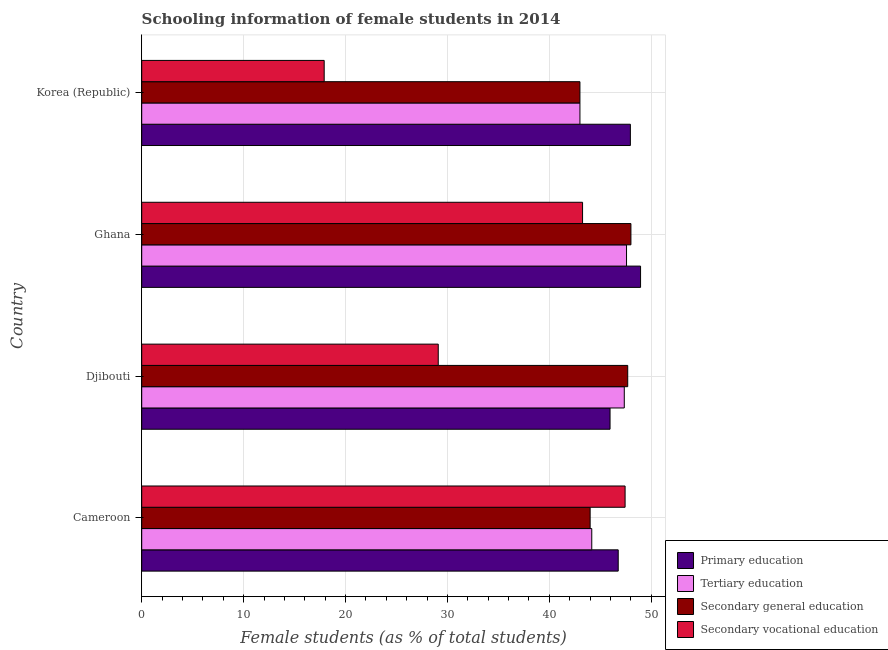How many groups of bars are there?
Your answer should be very brief. 4. How many bars are there on the 3rd tick from the bottom?
Give a very brief answer. 4. What is the label of the 2nd group of bars from the top?
Give a very brief answer. Ghana. In how many cases, is the number of bars for a given country not equal to the number of legend labels?
Offer a terse response. 0. What is the percentage of female students in secondary education in Cameroon?
Keep it short and to the point. 44. Across all countries, what is the maximum percentage of female students in secondary vocational education?
Make the answer very short. 47.43. Across all countries, what is the minimum percentage of female students in secondary education?
Keep it short and to the point. 43. In which country was the percentage of female students in secondary education maximum?
Offer a very short reply. Ghana. What is the total percentage of female students in secondary education in the graph?
Ensure brevity in your answer.  182.7. What is the difference between the percentage of female students in secondary vocational education in Korea (Republic) and the percentage of female students in secondary education in Djibouti?
Offer a very short reply. -29.79. What is the average percentage of female students in tertiary education per country?
Your response must be concise. 45.52. What is the difference between the percentage of female students in tertiary education and percentage of female students in secondary vocational education in Djibouti?
Provide a short and direct response. 18.26. What is the ratio of the percentage of female students in secondary vocational education in Djibouti to that in Korea (Republic)?
Give a very brief answer. 1.62. What is the difference between the highest and the second highest percentage of female students in tertiary education?
Your answer should be very brief. 0.22. What is the difference between the highest and the lowest percentage of female students in secondary vocational education?
Your answer should be very brief. 29.53. Is the sum of the percentage of female students in secondary education in Cameroon and Korea (Republic) greater than the maximum percentage of female students in tertiary education across all countries?
Keep it short and to the point. Yes. Is it the case that in every country, the sum of the percentage of female students in primary education and percentage of female students in secondary vocational education is greater than the sum of percentage of female students in secondary education and percentage of female students in tertiary education?
Give a very brief answer. No. Is it the case that in every country, the sum of the percentage of female students in primary education and percentage of female students in tertiary education is greater than the percentage of female students in secondary education?
Make the answer very short. Yes. How many bars are there?
Ensure brevity in your answer.  16. Are all the bars in the graph horizontal?
Keep it short and to the point. Yes. What is the difference between two consecutive major ticks on the X-axis?
Keep it short and to the point. 10. Are the values on the major ticks of X-axis written in scientific E-notation?
Give a very brief answer. No. Does the graph contain any zero values?
Ensure brevity in your answer.  No. Does the graph contain grids?
Offer a very short reply. Yes. Where does the legend appear in the graph?
Offer a very short reply. Bottom right. How many legend labels are there?
Ensure brevity in your answer.  4. What is the title of the graph?
Your answer should be very brief. Schooling information of female students in 2014. What is the label or title of the X-axis?
Your answer should be very brief. Female students (as % of total students). What is the label or title of the Y-axis?
Offer a very short reply. Country. What is the Female students (as % of total students) in Primary education in Cameroon?
Your response must be concise. 46.76. What is the Female students (as % of total students) in Tertiary education in Cameroon?
Keep it short and to the point. 44.16. What is the Female students (as % of total students) of Secondary general education in Cameroon?
Keep it short and to the point. 44. What is the Female students (as % of total students) in Secondary vocational education in Cameroon?
Your response must be concise. 47.43. What is the Female students (as % of total students) in Primary education in Djibouti?
Your answer should be compact. 45.96. What is the Female students (as % of total students) of Tertiary education in Djibouti?
Give a very brief answer. 47.35. What is the Female students (as % of total students) of Secondary general education in Djibouti?
Give a very brief answer. 47.69. What is the Female students (as % of total students) of Secondary vocational education in Djibouti?
Your answer should be compact. 29.1. What is the Female students (as % of total students) in Primary education in Ghana?
Provide a short and direct response. 48.95. What is the Female students (as % of total students) in Tertiary education in Ghana?
Make the answer very short. 47.58. What is the Female students (as % of total students) of Secondary general education in Ghana?
Provide a short and direct response. 48.01. What is the Female students (as % of total students) of Secondary vocational education in Ghana?
Offer a terse response. 43.26. What is the Female students (as % of total students) of Primary education in Korea (Republic)?
Offer a terse response. 47.95. What is the Female students (as % of total students) in Tertiary education in Korea (Republic)?
Your answer should be very brief. 43. What is the Female students (as % of total students) of Secondary general education in Korea (Republic)?
Make the answer very short. 43. What is the Female students (as % of total students) in Secondary vocational education in Korea (Republic)?
Give a very brief answer. 17.91. Across all countries, what is the maximum Female students (as % of total students) of Primary education?
Your answer should be very brief. 48.95. Across all countries, what is the maximum Female students (as % of total students) in Tertiary education?
Provide a short and direct response. 47.58. Across all countries, what is the maximum Female students (as % of total students) of Secondary general education?
Provide a succinct answer. 48.01. Across all countries, what is the maximum Female students (as % of total students) in Secondary vocational education?
Your answer should be compact. 47.43. Across all countries, what is the minimum Female students (as % of total students) of Primary education?
Your answer should be very brief. 45.96. Across all countries, what is the minimum Female students (as % of total students) in Tertiary education?
Offer a very short reply. 43. Across all countries, what is the minimum Female students (as % of total students) in Secondary general education?
Provide a short and direct response. 43. Across all countries, what is the minimum Female students (as % of total students) in Secondary vocational education?
Your response must be concise. 17.91. What is the total Female students (as % of total students) of Primary education in the graph?
Provide a succinct answer. 189.62. What is the total Female students (as % of total students) in Tertiary education in the graph?
Your answer should be compact. 182.1. What is the total Female students (as % of total students) in Secondary general education in the graph?
Your answer should be very brief. 182.7. What is the total Female students (as % of total students) in Secondary vocational education in the graph?
Your answer should be compact. 137.7. What is the difference between the Female students (as % of total students) of Primary education in Cameroon and that in Djibouti?
Offer a very short reply. 0.8. What is the difference between the Female students (as % of total students) in Tertiary education in Cameroon and that in Djibouti?
Your answer should be very brief. -3.19. What is the difference between the Female students (as % of total students) of Secondary general education in Cameroon and that in Djibouti?
Make the answer very short. -3.69. What is the difference between the Female students (as % of total students) of Secondary vocational education in Cameroon and that in Djibouti?
Ensure brevity in your answer.  18.34. What is the difference between the Female students (as % of total students) in Primary education in Cameroon and that in Ghana?
Provide a short and direct response. -2.19. What is the difference between the Female students (as % of total students) in Tertiary education in Cameroon and that in Ghana?
Ensure brevity in your answer.  -3.41. What is the difference between the Female students (as % of total students) of Secondary general education in Cameroon and that in Ghana?
Ensure brevity in your answer.  -4. What is the difference between the Female students (as % of total students) of Secondary vocational education in Cameroon and that in Ghana?
Keep it short and to the point. 4.17. What is the difference between the Female students (as % of total students) in Primary education in Cameroon and that in Korea (Republic)?
Your answer should be very brief. -1.19. What is the difference between the Female students (as % of total students) of Tertiary education in Cameroon and that in Korea (Republic)?
Ensure brevity in your answer.  1.16. What is the difference between the Female students (as % of total students) of Secondary vocational education in Cameroon and that in Korea (Republic)?
Keep it short and to the point. 29.53. What is the difference between the Female students (as % of total students) of Primary education in Djibouti and that in Ghana?
Your answer should be very brief. -2.99. What is the difference between the Female students (as % of total students) in Tertiary education in Djibouti and that in Ghana?
Offer a very short reply. -0.22. What is the difference between the Female students (as % of total students) in Secondary general education in Djibouti and that in Ghana?
Ensure brevity in your answer.  -0.31. What is the difference between the Female students (as % of total students) in Secondary vocational education in Djibouti and that in Ghana?
Your response must be concise. -14.16. What is the difference between the Female students (as % of total students) of Primary education in Djibouti and that in Korea (Republic)?
Your response must be concise. -2. What is the difference between the Female students (as % of total students) of Tertiary education in Djibouti and that in Korea (Republic)?
Offer a terse response. 4.35. What is the difference between the Female students (as % of total students) in Secondary general education in Djibouti and that in Korea (Republic)?
Ensure brevity in your answer.  4.69. What is the difference between the Female students (as % of total students) in Secondary vocational education in Djibouti and that in Korea (Republic)?
Offer a terse response. 11.19. What is the difference between the Female students (as % of total students) in Primary education in Ghana and that in Korea (Republic)?
Make the answer very short. 1. What is the difference between the Female students (as % of total students) in Tertiary education in Ghana and that in Korea (Republic)?
Your response must be concise. 4.57. What is the difference between the Female students (as % of total students) in Secondary general education in Ghana and that in Korea (Republic)?
Your answer should be compact. 5. What is the difference between the Female students (as % of total students) of Secondary vocational education in Ghana and that in Korea (Republic)?
Keep it short and to the point. 25.36. What is the difference between the Female students (as % of total students) of Primary education in Cameroon and the Female students (as % of total students) of Tertiary education in Djibouti?
Offer a terse response. -0.6. What is the difference between the Female students (as % of total students) in Primary education in Cameroon and the Female students (as % of total students) in Secondary general education in Djibouti?
Provide a short and direct response. -0.93. What is the difference between the Female students (as % of total students) of Primary education in Cameroon and the Female students (as % of total students) of Secondary vocational education in Djibouti?
Provide a short and direct response. 17.66. What is the difference between the Female students (as % of total students) in Tertiary education in Cameroon and the Female students (as % of total students) in Secondary general education in Djibouti?
Provide a short and direct response. -3.53. What is the difference between the Female students (as % of total students) of Tertiary education in Cameroon and the Female students (as % of total students) of Secondary vocational education in Djibouti?
Offer a terse response. 15.07. What is the difference between the Female students (as % of total students) of Secondary general education in Cameroon and the Female students (as % of total students) of Secondary vocational education in Djibouti?
Your answer should be compact. 14.91. What is the difference between the Female students (as % of total students) in Primary education in Cameroon and the Female students (as % of total students) in Tertiary education in Ghana?
Give a very brief answer. -0.82. What is the difference between the Female students (as % of total students) in Primary education in Cameroon and the Female students (as % of total students) in Secondary general education in Ghana?
Make the answer very short. -1.25. What is the difference between the Female students (as % of total students) in Primary education in Cameroon and the Female students (as % of total students) in Secondary vocational education in Ghana?
Your answer should be very brief. 3.5. What is the difference between the Female students (as % of total students) in Tertiary education in Cameroon and the Female students (as % of total students) in Secondary general education in Ghana?
Your answer should be very brief. -3.84. What is the difference between the Female students (as % of total students) in Tertiary education in Cameroon and the Female students (as % of total students) in Secondary vocational education in Ghana?
Provide a succinct answer. 0.9. What is the difference between the Female students (as % of total students) in Secondary general education in Cameroon and the Female students (as % of total students) in Secondary vocational education in Ghana?
Provide a short and direct response. 0.74. What is the difference between the Female students (as % of total students) in Primary education in Cameroon and the Female students (as % of total students) in Tertiary education in Korea (Republic)?
Offer a very short reply. 3.76. What is the difference between the Female students (as % of total students) in Primary education in Cameroon and the Female students (as % of total students) in Secondary general education in Korea (Republic)?
Offer a terse response. 3.76. What is the difference between the Female students (as % of total students) of Primary education in Cameroon and the Female students (as % of total students) of Secondary vocational education in Korea (Republic)?
Your answer should be compact. 28.85. What is the difference between the Female students (as % of total students) in Tertiary education in Cameroon and the Female students (as % of total students) in Secondary general education in Korea (Republic)?
Give a very brief answer. 1.16. What is the difference between the Female students (as % of total students) of Tertiary education in Cameroon and the Female students (as % of total students) of Secondary vocational education in Korea (Republic)?
Offer a very short reply. 26.26. What is the difference between the Female students (as % of total students) in Secondary general education in Cameroon and the Female students (as % of total students) in Secondary vocational education in Korea (Republic)?
Your response must be concise. 26.1. What is the difference between the Female students (as % of total students) of Primary education in Djibouti and the Female students (as % of total students) of Tertiary education in Ghana?
Give a very brief answer. -1.62. What is the difference between the Female students (as % of total students) in Primary education in Djibouti and the Female students (as % of total students) in Secondary general education in Ghana?
Provide a succinct answer. -2.05. What is the difference between the Female students (as % of total students) of Primary education in Djibouti and the Female students (as % of total students) of Secondary vocational education in Ghana?
Your answer should be very brief. 2.7. What is the difference between the Female students (as % of total students) of Tertiary education in Djibouti and the Female students (as % of total students) of Secondary general education in Ghana?
Your answer should be very brief. -0.65. What is the difference between the Female students (as % of total students) in Tertiary education in Djibouti and the Female students (as % of total students) in Secondary vocational education in Ghana?
Offer a very short reply. 4.09. What is the difference between the Female students (as % of total students) in Secondary general education in Djibouti and the Female students (as % of total students) in Secondary vocational education in Ghana?
Offer a very short reply. 4.43. What is the difference between the Female students (as % of total students) of Primary education in Djibouti and the Female students (as % of total students) of Tertiary education in Korea (Republic)?
Make the answer very short. 2.95. What is the difference between the Female students (as % of total students) of Primary education in Djibouti and the Female students (as % of total students) of Secondary general education in Korea (Republic)?
Offer a terse response. 2.95. What is the difference between the Female students (as % of total students) in Primary education in Djibouti and the Female students (as % of total students) in Secondary vocational education in Korea (Republic)?
Provide a short and direct response. 28.05. What is the difference between the Female students (as % of total students) of Tertiary education in Djibouti and the Female students (as % of total students) of Secondary general education in Korea (Republic)?
Ensure brevity in your answer.  4.35. What is the difference between the Female students (as % of total students) in Tertiary education in Djibouti and the Female students (as % of total students) in Secondary vocational education in Korea (Republic)?
Offer a very short reply. 29.45. What is the difference between the Female students (as % of total students) of Secondary general education in Djibouti and the Female students (as % of total students) of Secondary vocational education in Korea (Republic)?
Your response must be concise. 29.79. What is the difference between the Female students (as % of total students) of Primary education in Ghana and the Female students (as % of total students) of Tertiary education in Korea (Republic)?
Provide a short and direct response. 5.95. What is the difference between the Female students (as % of total students) of Primary education in Ghana and the Female students (as % of total students) of Secondary general education in Korea (Republic)?
Provide a succinct answer. 5.95. What is the difference between the Female students (as % of total students) in Primary education in Ghana and the Female students (as % of total students) in Secondary vocational education in Korea (Republic)?
Give a very brief answer. 31.05. What is the difference between the Female students (as % of total students) in Tertiary education in Ghana and the Female students (as % of total students) in Secondary general education in Korea (Republic)?
Your answer should be very brief. 4.57. What is the difference between the Female students (as % of total students) of Tertiary education in Ghana and the Female students (as % of total students) of Secondary vocational education in Korea (Republic)?
Keep it short and to the point. 29.67. What is the difference between the Female students (as % of total students) of Secondary general education in Ghana and the Female students (as % of total students) of Secondary vocational education in Korea (Republic)?
Offer a very short reply. 30.1. What is the average Female students (as % of total students) in Primary education per country?
Your answer should be very brief. 47.4. What is the average Female students (as % of total students) of Tertiary education per country?
Offer a terse response. 45.52. What is the average Female students (as % of total students) in Secondary general education per country?
Offer a terse response. 45.68. What is the average Female students (as % of total students) of Secondary vocational education per country?
Keep it short and to the point. 34.42. What is the difference between the Female students (as % of total students) of Primary education and Female students (as % of total students) of Tertiary education in Cameroon?
Offer a very short reply. 2.6. What is the difference between the Female students (as % of total students) in Primary education and Female students (as % of total students) in Secondary general education in Cameroon?
Your answer should be compact. 2.75. What is the difference between the Female students (as % of total students) of Primary education and Female students (as % of total students) of Secondary vocational education in Cameroon?
Make the answer very short. -0.68. What is the difference between the Female students (as % of total students) in Tertiary education and Female students (as % of total students) in Secondary general education in Cameroon?
Your answer should be compact. 0.16. What is the difference between the Female students (as % of total students) of Tertiary education and Female students (as % of total students) of Secondary vocational education in Cameroon?
Your answer should be compact. -3.27. What is the difference between the Female students (as % of total students) of Secondary general education and Female students (as % of total students) of Secondary vocational education in Cameroon?
Offer a terse response. -3.43. What is the difference between the Female students (as % of total students) of Primary education and Female students (as % of total students) of Tertiary education in Djibouti?
Keep it short and to the point. -1.4. What is the difference between the Female students (as % of total students) in Primary education and Female students (as % of total students) in Secondary general education in Djibouti?
Provide a short and direct response. -1.73. What is the difference between the Female students (as % of total students) in Primary education and Female students (as % of total students) in Secondary vocational education in Djibouti?
Your answer should be compact. 16.86. What is the difference between the Female students (as % of total students) in Tertiary education and Female students (as % of total students) in Secondary general education in Djibouti?
Ensure brevity in your answer.  -0.34. What is the difference between the Female students (as % of total students) in Tertiary education and Female students (as % of total students) in Secondary vocational education in Djibouti?
Your answer should be very brief. 18.26. What is the difference between the Female students (as % of total students) of Secondary general education and Female students (as % of total students) of Secondary vocational education in Djibouti?
Give a very brief answer. 18.59. What is the difference between the Female students (as % of total students) of Primary education and Female students (as % of total students) of Tertiary education in Ghana?
Ensure brevity in your answer.  1.38. What is the difference between the Female students (as % of total students) of Primary education and Female students (as % of total students) of Secondary general education in Ghana?
Your response must be concise. 0.95. What is the difference between the Female students (as % of total students) in Primary education and Female students (as % of total students) in Secondary vocational education in Ghana?
Keep it short and to the point. 5.69. What is the difference between the Female students (as % of total students) in Tertiary education and Female students (as % of total students) in Secondary general education in Ghana?
Ensure brevity in your answer.  -0.43. What is the difference between the Female students (as % of total students) in Tertiary education and Female students (as % of total students) in Secondary vocational education in Ghana?
Keep it short and to the point. 4.31. What is the difference between the Female students (as % of total students) of Secondary general education and Female students (as % of total students) of Secondary vocational education in Ghana?
Your answer should be very brief. 4.74. What is the difference between the Female students (as % of total students) in Primary education and Female students (as % of total students) in Tertiary education in Korea (Republic)?
Give a very brief answer. 4.95. What is the difference between the Female students (as % of total students) of Primary education and Female students (as % of total students) of Secondary general education in Korea (Republic)?
Make the answer very short. 4.95. What is the difference between the Female students (as % of total students) of Primary education and Female students (as % of total students) of Secondary vocational education in Korea (Republic)?
Your answer should be compact. 30.05. What is the difference between the Female students (as % of total students) of Tertiary education and Female students (as % of total students) of Secondary general education in Korea (Republic)?
Offer a very short reply. 0. What is the difference between the Female students (as % of total students) in Tertiary education and Female students (as % of total students) in Secondary vocational education in Korea (Republic)?
Your answer should be very brief. 25.1. What is the difference between the Female students (as % of total students) in Secondary general education and Female students (as % of total students) in Secondary vocational education in Korea (Republic)?
Your answer should be compact. 25.1. What is the ratio of the Female students (as % of total students) of Primary education in Cameroon to that in Djibouti?
Give a very brief answer. 1.02. What is the ratio of the Female students (as % of total students) of Tertiary education in Cameroon to that in Djibouti?
Your answer should be compact. 0.93. What is the ratio of the Female students (as % of total students) of Secondary general education in Cameroon to that in Djibouti?
Offer a very short reply. 0.92. What is the ratio of the Female students (as % of total students) in Secondary vocational education in Cameroon to that in Djibouti?
Make the answer very short. 1.63. What is the ratio of the Female students (as % of total students) of Primary education in Cameroon to that in Ghana?
Make the answer very short. 0.96. What is the ratio of the Female students (as % of total students) in Tertiary education in Cameroon to that in Ghana?
Provide a short and direct response. 0.93. What is the ratio of the Female students (as % of total students) in Secondary general education in Cameroon to that in Ghana?
Keep it short and to the point. 0.92. What is the ratio of the Female students (as % of total students) of Secondary vocational education in Cameroon to that in Ghana?
Ensure brevity in your answer.  1.1. What is the ratio of the Female students (as % of total students) of Primary education in Cameroon to that in Korea (Republic)?
Give a very brief answer. 0.98. What is the ratio of the Female students (as % of total students) of Secondary general education in Cameroon to that in Korea (Republic)?
Offer a terse response. 1.02. What is the ratio of the Female students (as % of total students) of Secondary vocational education in Cameroon to that in Korea (Republic)?
Offer a very short reply. 2.65. What is the ratio of the Female students (as % of total students) of Primary education in Djibouti to that in Ghana?
Keep it short and to the point. 0.94. What is the ratio of the Female students (as % of total students) in Secondary general education in Djibouti to that in Ghana?
Make the answer very short. 0.99. What is the ratio of the Female students (as % of total students) of Secondary vocational education in Djibouti to that in Ghana?
Ensure brevity in your answer.  0.67. What is the ratio of the Female students (as % of total students) in Primary education in Djibouti to that in Korea (Republic)?
Give a very brief answer. 0.96. What is the ratio of the Female students (as % of total students) of Tertiary education in Djibouti to that in Korea (Republic)?
Make the answer very short. 1.1. What is the ratio of the Female students (as % of total students) of Secondary general education in Djibouti to that in Korea (Republic)?
Make the answer very short. 1.11. What is the ratio of the Female students (as % of total students) in Secondary vocational education in Djibouti to that in Korea (Republic)?
Offer a very short reply. 1.63. What is the ratio of the Female students (as % of total students) in Primary education in Ghana to that in Korea (Republic)?
Your answer should be very brief. 1.02. What is the ratio of the Female students (as % of total students) of Tertiary education in Ghana to that in Korea (Republic)?
Offer a terse response. 1.11. What is the ratio of the Female students (as % of total students) of Secondary general education in Ghana to that in Korea (Republic)?
Provide a short and direct response. 1.12. What is the ratio of the Female students (as % of total students) of Secondary vocational education in Ghana to that in Korea (Republic)?
Offer a terse response. 2.42. What is the difference between the highest and the second highest Female students (as % of total students) in Tertiary education?
Make the answer very short. 0.22. What is the difference between the highest and the second highest Female students (as % of total students) in Secondary general education?
Offer a terse response. 0.31. What is the difference between the highest and the second highest Female students (as % of total students) of Secondary vocational education?
Your response must be concise. 4.17. What is the difference between the highest and the lowest Female students (as % of total students) of Primary education?
Ensure brevity in your answer.  2.99. What is the difference between the highest and the lowest Female students (as % of total students) of Tertiary education?
Ensure brevity in your answer.  4.57. What is the difference between the highest and the lowest Female students (as % of total students) in Secondary general education?
Your answer should be very brief. 5. What is the difference between the highest and the lowest Female students (as % of total students) of Secondary vocational education?
Provide a short and direct response. 29.53. 